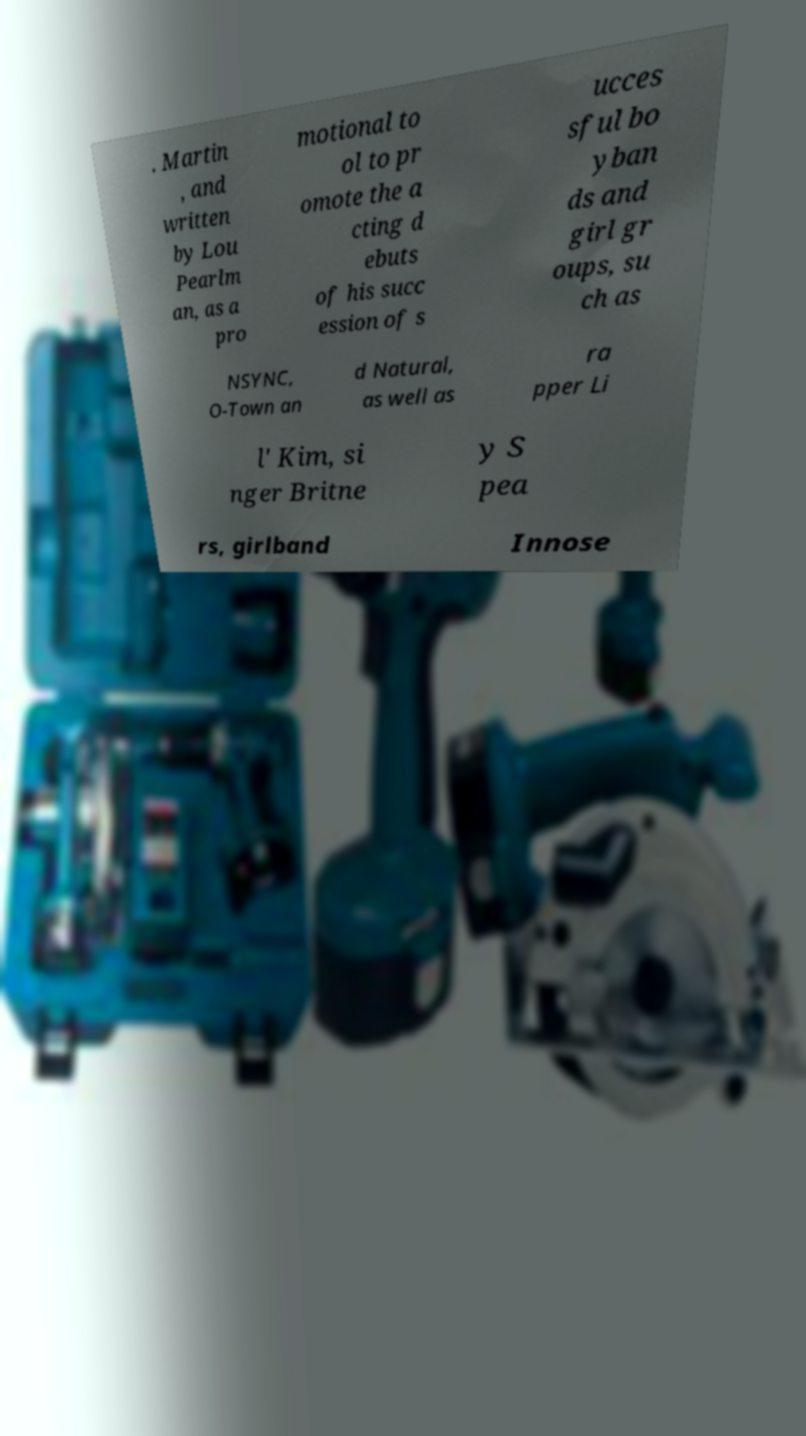What messages or text are displayed in this image? I need them in a readable, typed format. . Martin , and written by Lou Pearlm an, as a pro motional to ol to pr omote the a cting d ebuts of his succ ession of s ucces sful bo yban ds and girl gr oups, su ch as NSYNC, O-Town an d Natural, as well as ra pper Li l' Kim, si nger Britne y S pea rs, girlband Innose 